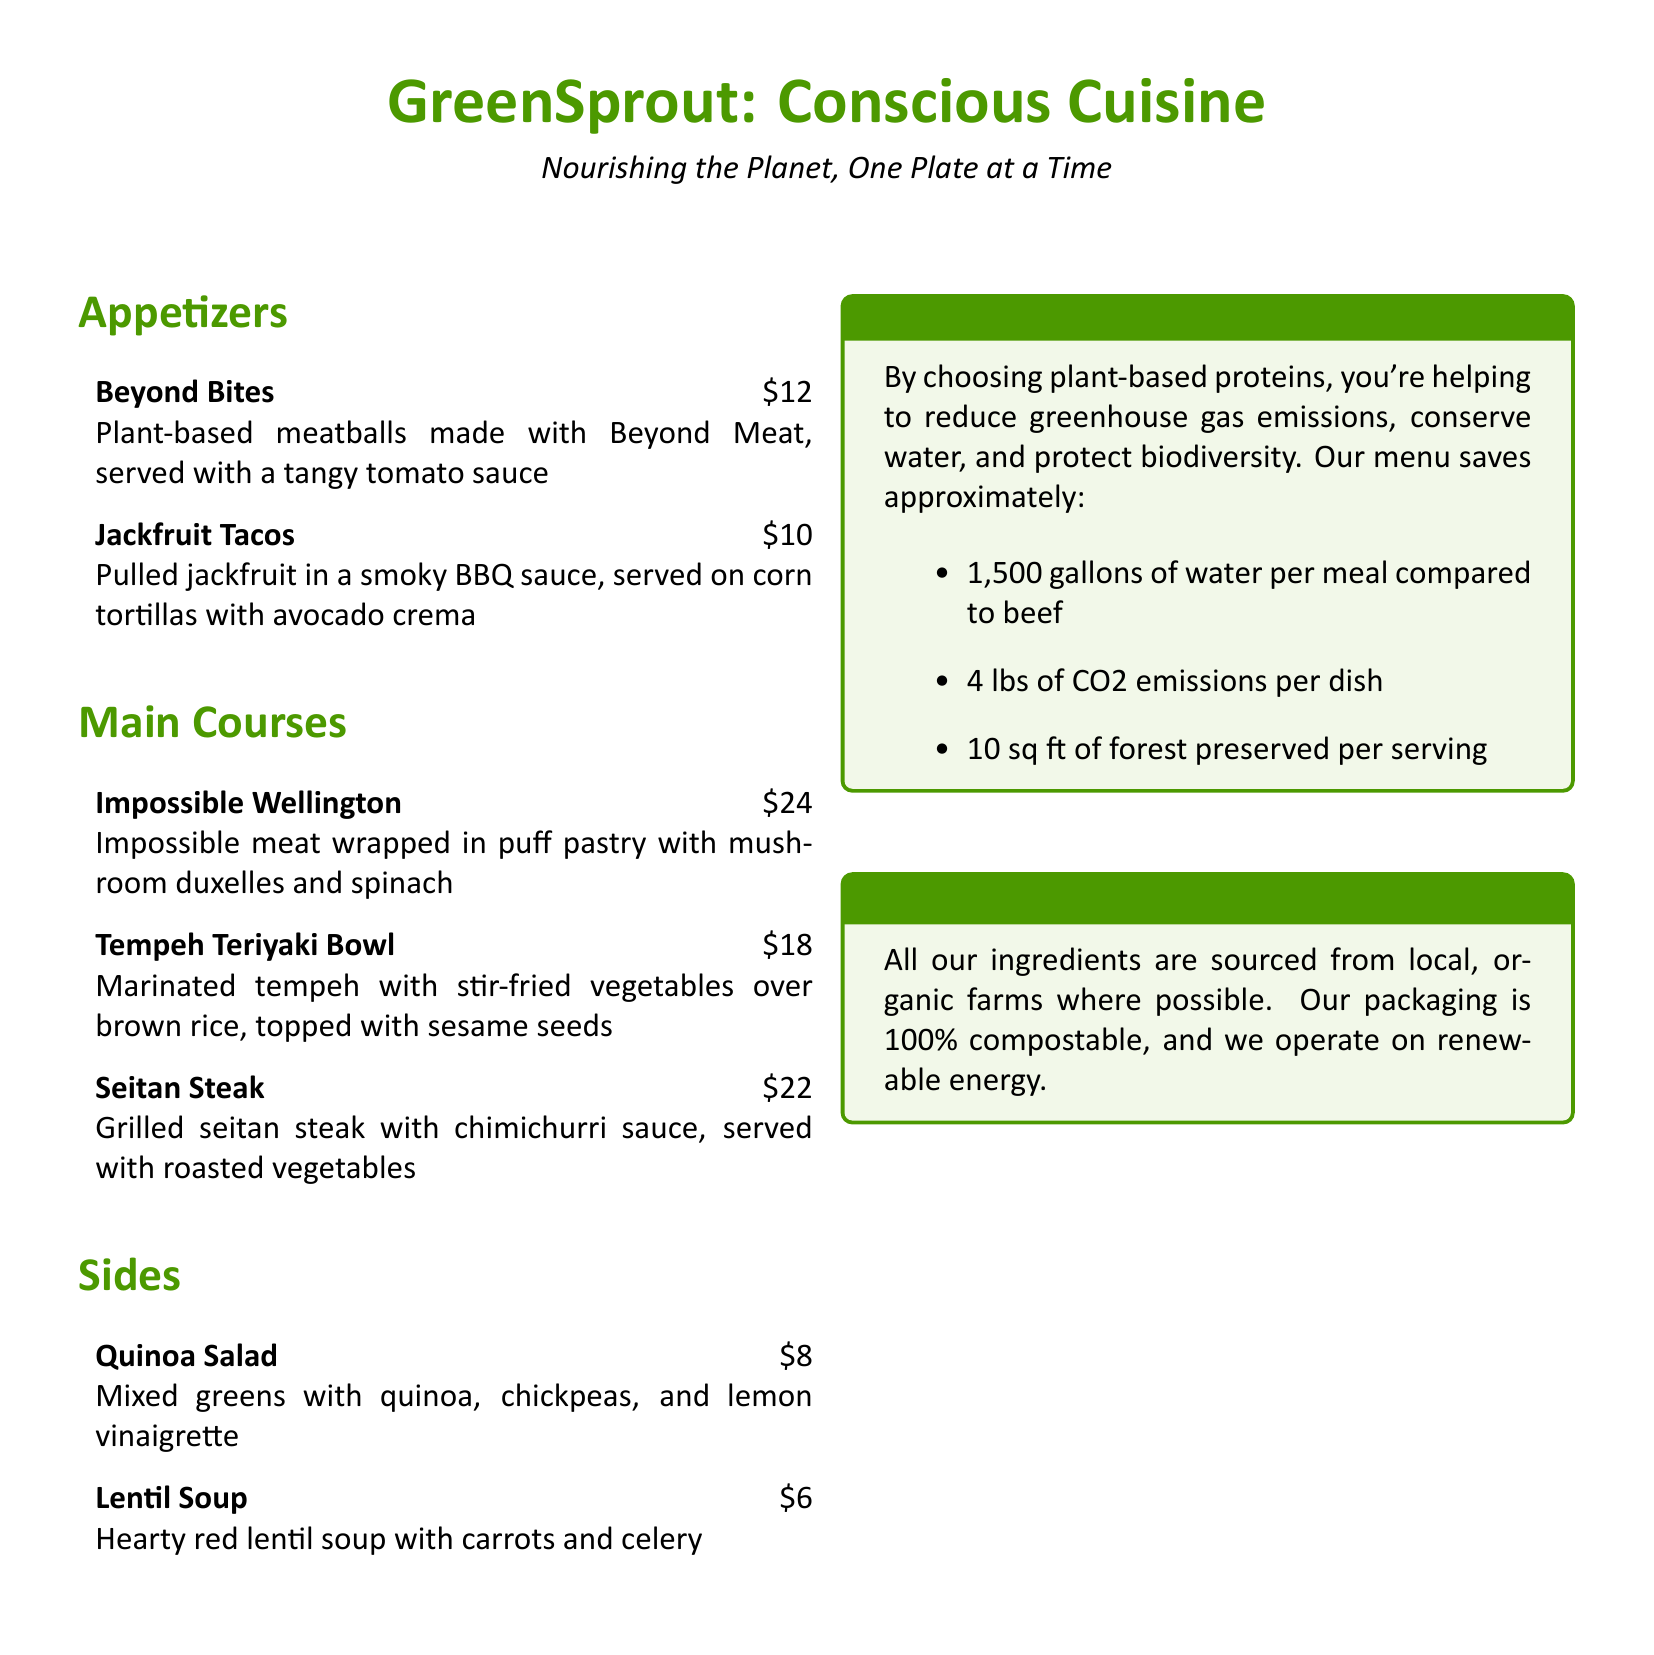What are Beyond Bites made from? Beyond Bites are made with Beyond Meat, a plant-based alternative.
Answer: Beyond Meat How much does the Impossible Wellington cost? The price of the Impossible Wellington is listed in the menu under Main Courses.
Answer: $24 What kind of protein source is used in Jackfruit Tacos? Jackfruit Tacos use jackfruit, which is a plant-based meat alternative.
Answer: Jackfruit How many gallons of water per meal does the menu claim to save compared to beef? The document states specific water savings compared to beef on the commitment to the planet.
Answer: 1,500 gallons What is included in the Tempeh Teriyaki Bowl? The Tempeh Teriyaki Bowl features marinated tempeh with stir-fried vegetables over brown rice.
Answer: Marinated tempeh, stir-fried vegetables, brown rice Which side dish has a price of $6? The price designation indicates the cost of the Lentil Soup in the Sides section.
Answer: Lentil Soup What is the sustainability note about packaging? The sustainability note provides information on the type of packaging used for takeout and dining.
Answer: 100% compostable How much CO2 emissions does the menu claim to reduce per dish? The commitment to the planet section mentions the CO2 emissions reduction achieved through plant-based dishes.
Answer: 4 lbs of CO2 emissions 